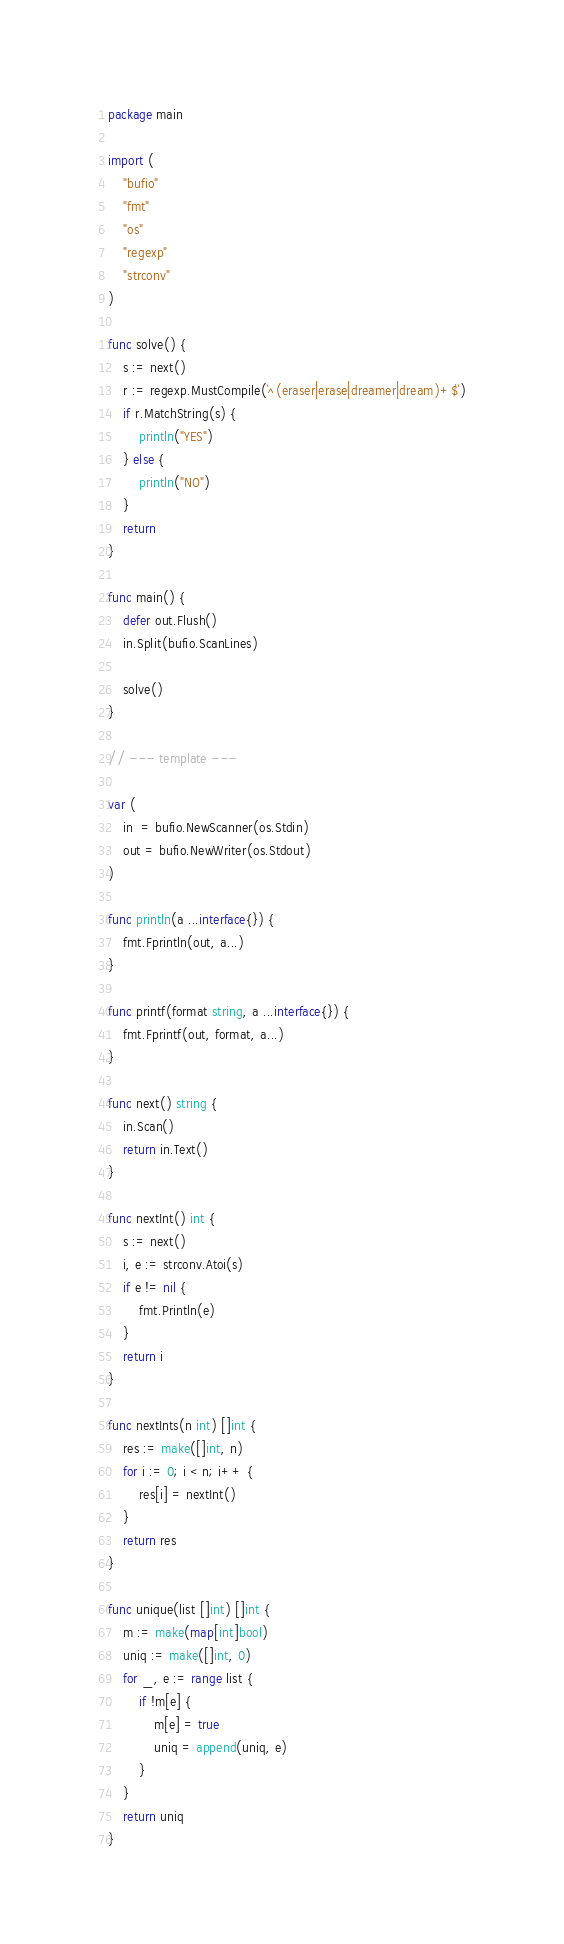Convert code to text. <code><loc_0><loc_0><loc_500><loc_500><_Go_>package main

import (
	"bufio"
	"fmt"
	"os"
	"regexp"
	"strconv"
)

func solve() {
	s := next()
	r := regexp.MustCompile(`^(eraser|erase|dreamer|dream)+$`)
	if r.MatchString(s) {
		println("YES")
	} else {
		println("NO")
	}
	return
}

func main() {
	defer out.Flush()
	in.Split(bufio.ScanLines)

	solve()
}

// --- template ---

var (
	in  = bufio.NewScanner(os.Stdin)
	out = bufio.NewWriter(os.Stdout)
)

func println(a ...interface{}) {
	fmt.Fprintln(out, a...)
}

func printf(format string, a ...interface{}) {
	fmt.Fprintf(out, format, a...)
}

func next() string {
	in.Scan()
	return in.Text()
}

func nextInt() int {
	s := next()
	i, e := strconv.Atoi(s)
	if e != nil {
		fmt.Println(e)
	}
	return i
}

func nextInts(n int) []int {
	res := make([]int, n)
	for i := 0; i < n; i++ {
		res[i] = nextInt()
	}
	return res
}

func unique(list []int) []int {
	m := make(map[int]bool)
	uniq := make([]int, 0)
	for _, e := range list {
		if !m[e] {
			m[e] = true
			uniq = append(uniq, e)
		}
	}
	return uniq
}
</code> 